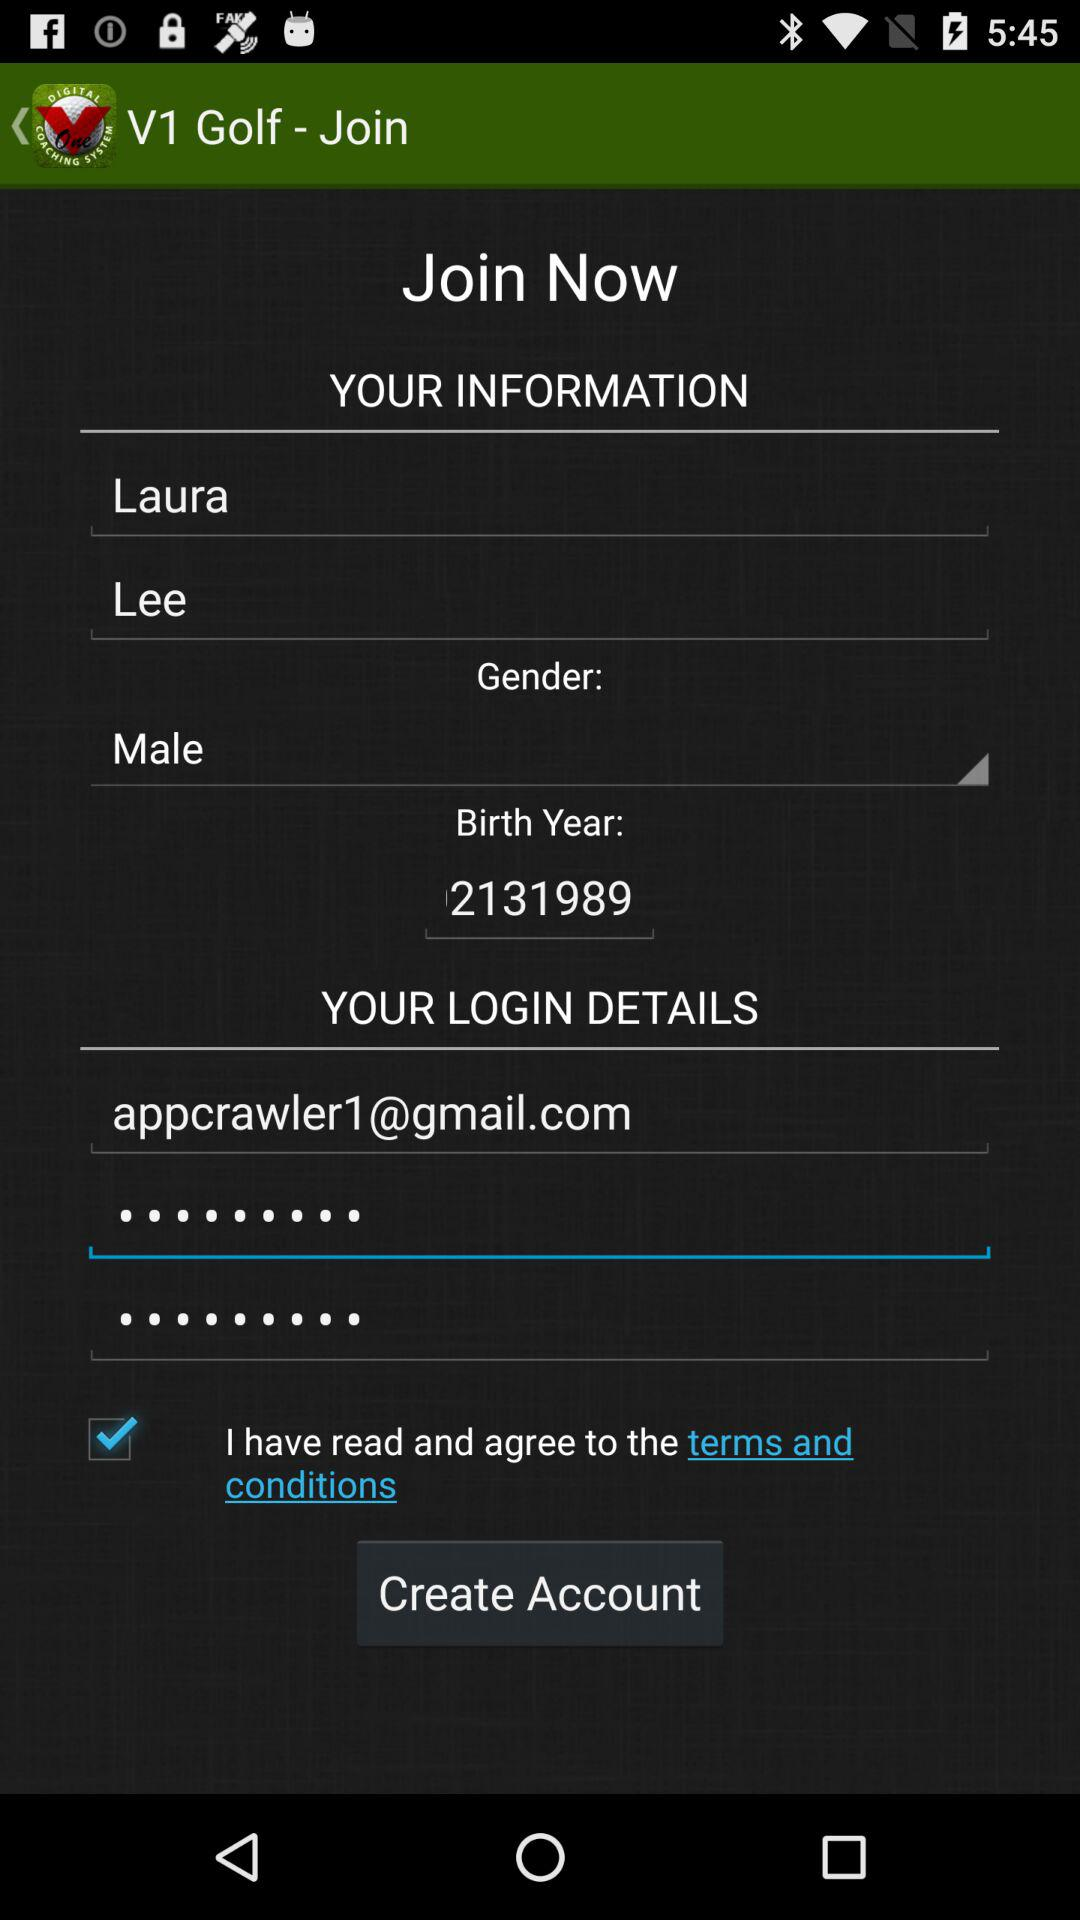On which date does Laura celebrate his birthday? Laura celebrates his birthday on February 13. 